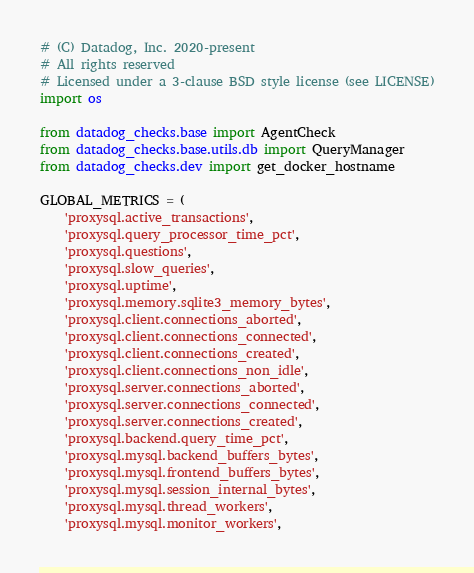<code> <loc_0><loc_0><loc_500><loc_500><_Python_># (C) Datadog, Inc. 2020-present
# All rights reserved
# Licensed under a 3-clause BSD style license (see LICENSE)
import os

from datadog_checks.base import AgentCheck
from datadog_checks.base.utils.db import QueryManager
from datadog_checks.dev import get_docker_hostname

GLOBAL_METRICS = (
    'proxysql.active_transactions',
    'proxysql.query_processor_time_pct',
    'proxysql.questions',
    'proxysql.slow_queries',
    'proxysql.uptime',
    'proxysql.memory.sqlite3_memory_bytes',
    'proxysql.client.connections_aborted',
    'proxysql.client.connections_connected',
    'proxysql.client.connections_created',
    'proxysql.client.connections_non_idle',
    'proxysql.server.connections_aborted',
    'proxysql.server.connections_connected',
    'proxysql.server.connections_created',
    'proxysql.backend.query_time_pct',
    'proxysql.mysql.backend_buffers_bytes',
    'proxysql.mysql.frontend_buffers_bytes',
    'proxysql.mysql.session_internal_bytes',
    'proxysql.mysql.thread_workers',
    'proxysql.mysql.monitor_workers',</code> 